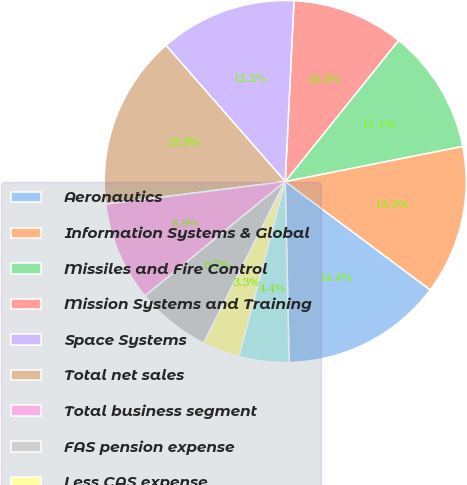<chart> <loc_0><loc_0><loc_500><loc_500><pie_chart><fcel>Aeronautics<fcel>Information Systems & Global<fcel>Missiles and Fire Control<fcel>Mission Systems and Training<fcel>Space Systems<fcel>Total net sales<fcel>Total business segment<fcel>FAS pension expense<fcel>Less CAS expense<fcel>Non-cash FAS/CAS pension<nl><fcel>14.44%<fcel>13.33%<fcel>11.11%<fcel>10.0%<fcel>12.22%<fcel>15.55%<fcel>8.89%<fcel>6.67%<fcel>3.34%<fcel>4.45%<nl></chart> 